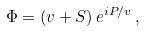Convert formula to latex. <formula><loc_0><loc_0><loc_500><loc_500>\Phi = \left ( v + S \right ) e ^ { i P / v } \, ,</formula> 